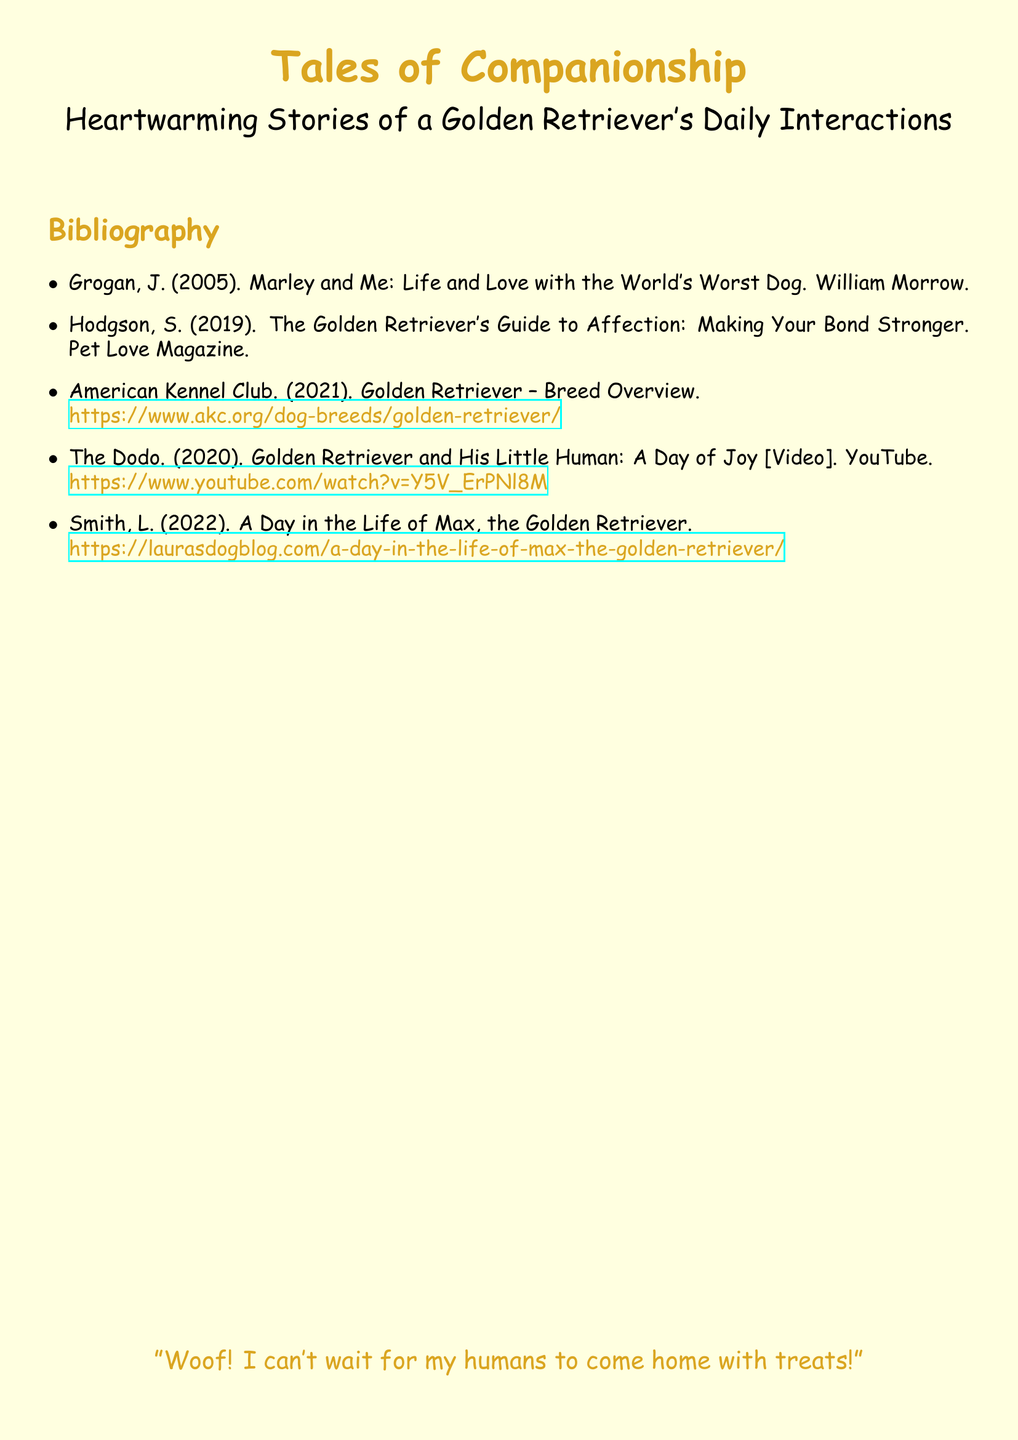What is the title of the document? The title of the document is stated at the top in a large font.
Answer: Tales of Companionship Who is the author of "Marley and Me"? The document lists the author of this book in the bibliography section.
Answer: Grogan What year was "The Golden Retriever's Guide to Affection" published? The publication year is mentioned alongside the title in the bibliography.
Answer: 2019 Which organization provided an overview of the Golden Retriever? The document mentions a specific organization related to dog breeds.
Answer: American Kennel Club What type of media is "Golden Retriever and His Little Human: A Day of Joy"? The document classifies this entry under a specific type of content.
Answer: Video How many items are listed in the bibliography? Counting the entries in the bibliography gives the total number of items.
Answer: 5 What breed of dog is the focus of this document? The document is centered on stories related to a specific dog breed.
Answer: Golden Retriever What color is used for the main font in the document? The color used for the title and headings is mentioned in the formatting section.
Answer: Goldenrod 